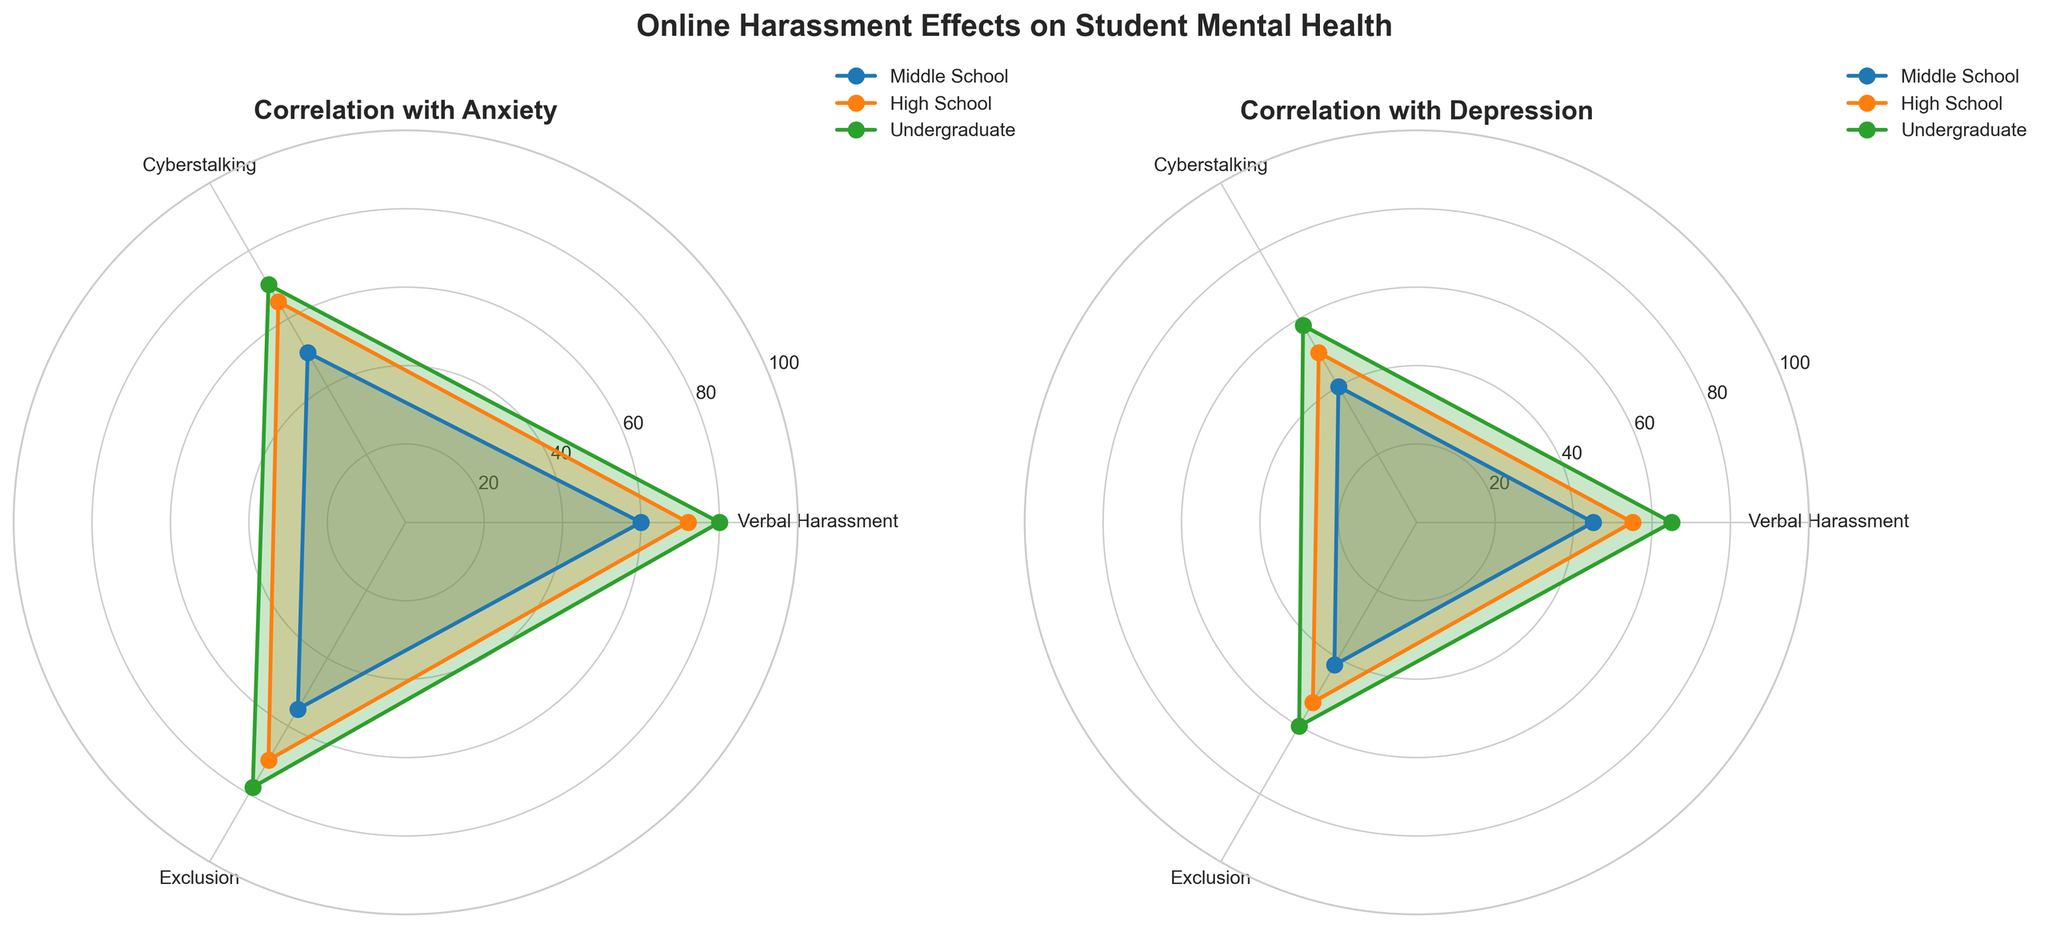What types of online harassment are included in the study? The title and axes of the radar chart indicate that the study examines Verbal Harassment, Cyberstalking, and Exclusion as types of online harassment.
Answer: Verbal Harassment, Cyberstalking, Exclusion Which group experiences the highest level of anxiety from Verbal Harassment? By looking at the radar chart for the 'Anxiety' plot, we see that the Undergraduate group has the highest value at the Verbal Harassment point.
Answer: Undergraduate Compare the anxiety levels from Cyberstalking among High School and Middle School students. On the radar chart under the 'Anxiety' section, the values for Cyberstalking are 65 for High School and 50 for Middle School.
Answer: High School has higher anxiety levels than Middle School What is the average depression level from Exclusion across all student groups? The depression levels from Exclusion for Middle School, High School, and Undergraduate are 42, 53, and 60, respectively. Adding these and dividing by 3 gives (42+53+60)/3 = 51.67.
Answer: 51.67 Which student group exhibits the least depression from Cyberstalking? In the radar chart for 'Depression', the Cyberstalking levels are shown as 40 for Middle School, 50 for High School, and 58 for Undergraduate. Middle School has the lowest value.
Answer: Middle School Is there a student group that consistently experiences higher anxiety across all types of online harassment? By examining the 'Anxiety' radar chart, Undergraduate students consistently show the highest values for Verbal Harassment (80), Cyberstalking (70), and Exclusion (78).
Answer: Yes, Undergraduate What is the sum of the anxiety levels caused by Exclusion in Middle School and High School students? In the 'Anxiety' radar chart, Exclusion levels are 55 for Middle School and 70 for High School. Adding these together gives 55 + 70 = 125.
Answer: 125 How much greater is the anxiety due to Verbal Harassment in High School students compared to Middle School students? In the 'Anxiety' radar chart, Verbal Harassment levels are 72 for High School and 60 for Middle School. Subtracting these gives 72 - 60 = 12.
Answer: 12 Which type of online harassment causes the least anxiety for High School students? In the 'Anxiety' radar chart for High School students, Verbal Harassment is 72, Cyberstalking is 65, and Exclusion is 70. The lowest value is for Cyberstalking at 65.
Answer: Cyberstalking Are the depression levels for Verbal Harassment higher or lower than those for Cyberstalking in Undergraduate students? By looking at the 'Depression' radar chart, Verbal Harassment has a value of 65 and Cyberstalking has 58 for Undergraduate students. Verbal Harassment is higher.
Answer: Higher 